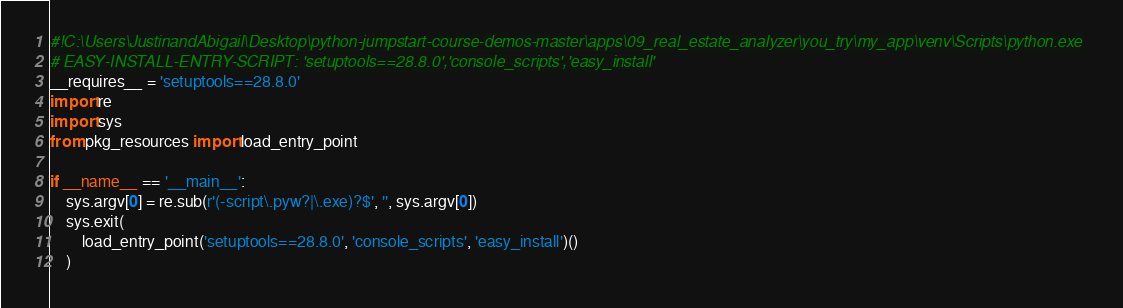<code> <loc_0><loc_0><loc_500><loc_500><_Python_>#!C:\Users\JustinandAbigail\Desktop\python-jumpstart-course-demos-master\apps\09_real_estate_analyzer\you_try\my_app\venv\Scripts\python.exe
# EASY-INSTALL-ENTRY-SCRIPT: 'setuptools==28.8.0','console_scripts','easy_install'
__requires__ = 'setuptools==28.8.0'
import re
import sys
from pkg_resources import load_entry_point

if __name__ == '__main__':
    sys.argv[0] = re.sub(r'(-script\.pyw?|\.exe)?$', '', sys.argv[0])
    sys.exit(
        load_entry_point('setuptools==28.8.0', 'console_scripts', 'easy_install')()
    )
</code> 